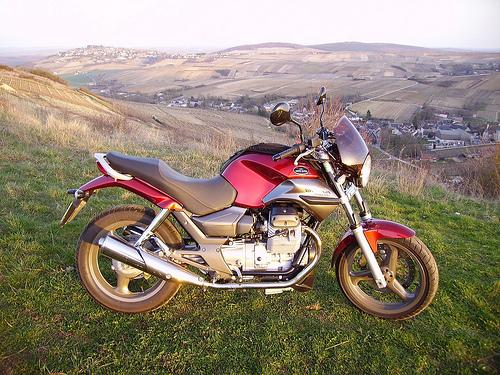What type of landscape is the image set in and what are some elements of the scene? The image is set in a countryside landscape, with elements like green grass, farm land, and a village in the background. In the context of colors and materials, describe the motorcycle's seat and mirrors. The seat of the motorcycle is black, and the mirrors are black and shiny. What aspects of the landscape can be seen in the image? Fields in the mountainside, green grass, and cloudy skies can be seen in the landscape. What is the main object in the image and where is it placed? The main object is a red motorcycle, placed on grass beside a hill. Count the number of houses in the image and describe the overall setting. There are 9 houses in the image, situated in a rural valley surrounded by farm land and grassy hills. What are the colors of the grass in the image? The grass is green, brown, and turning brown in some areas. Identify the primary object in the image and mention its color and any visible features. The primary object is a motorcycle, which is red and has features like a headlight, exhaust pipe, and farrings. Describe the type of building structures in the background. The background features rural houses and village buildings in the valley. Mention the type of vehicle in the image and the color of the wheels. The vehicle is a motorcycle, and the color of the wheels is grey. Name two things that the motorcycle has on its front side. The motorcycle has a headlight and farrings on its front side. 